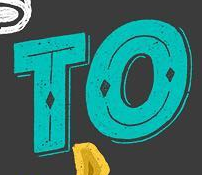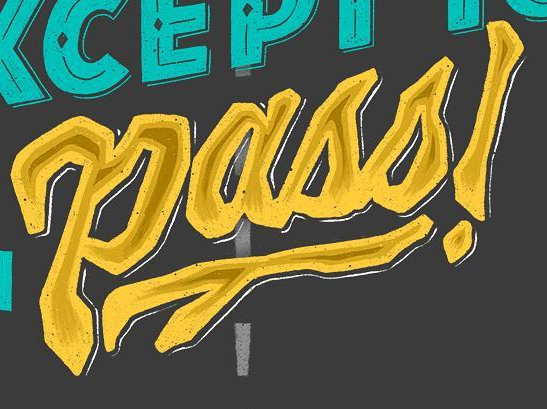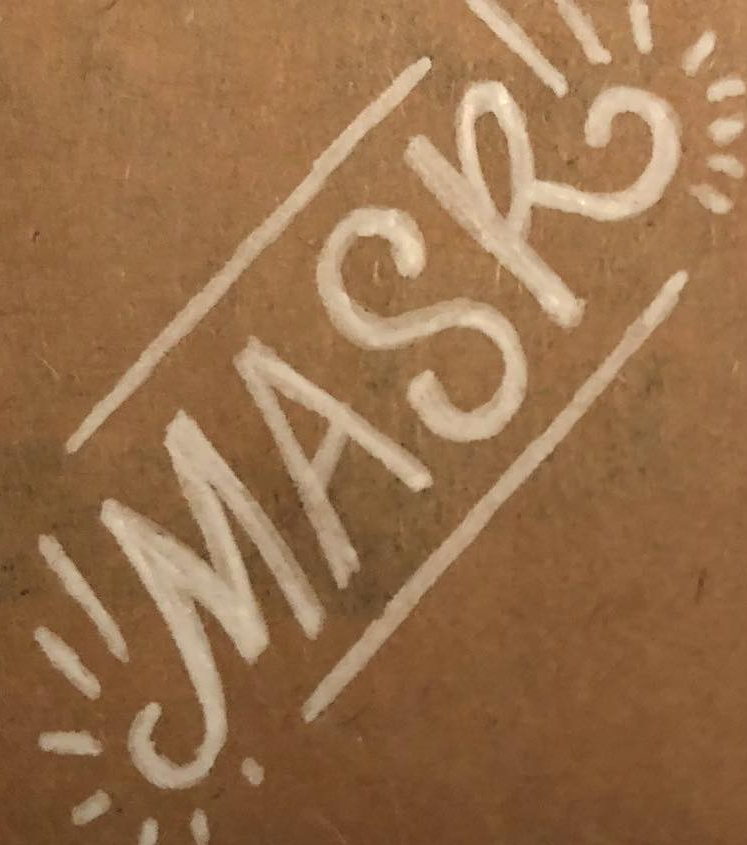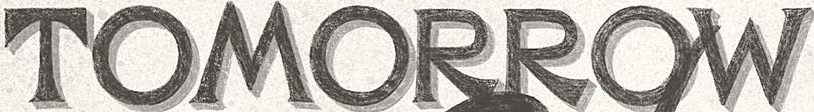What words are shown in these images in order, separated by a semicolon? TO; Pass!; MASK; TOMORROW 